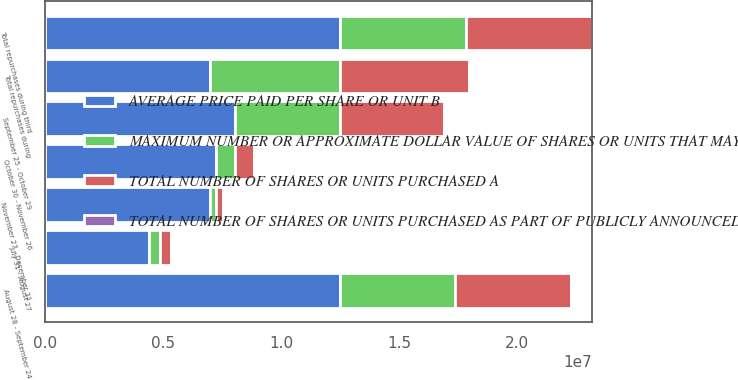Convert chart. <chart><loc_0><loc_0><loc_500><loc_500><stacked_bar_chart><ecel><fcel>July 31 - August 27<fcel>August 28 - September 24<fcel>Total repurchases during third<fcel>September 25 - October 29<fcel>October 30 - November 26<fcel>November 27 - December 31<fcel>Total repurchases during<nl><fcel>MAXIMUM NUMBER OR APPROXIMATE DOLLAR VALUE OF SHARES OR UNITS THAT MAY YET BE PURCHASED UNDER THE PLANS OR PROGRAMS D<fcel>452600<fcel>4.8945e+06<fcel>5.3471e+06<fcel>4.4249e+06<fcel>788300<fcel>266500<fcel>5.4797e+06<nl><fcel>TOTAL NUMBER OF SHARES OR UNITS PURCHASED AS PART OF PUBLICLY ANNOUNCED PLANS OR PROGRAMS C<fcel>61.02<fcel>62.13<fcel>62.04<fcel>61.62<fcel>63.82<fcel>63.85<fcel>62.05<nl><fcel>TOTAL NUMBER OF SHARES OR UNITS PURCHASED A<fcel>452600<fcel>4.8945e+06<fcel>5.3471e+06<fcel>4.4249e+06<fcel>788300<fcel>266500<fcel>5.4797e+06<nl><fcel>AVERAGE PRICE PAID PER SHARE OR UNIT B<fcel>4.4249e+06<fcel>1.24791e+07<fcel>1.24791e+07<fcel>8.0542e+06<fcel>7.2659e+06<fcel>6.9994e+06<fcel>6.9994e+06<nl></chart> 